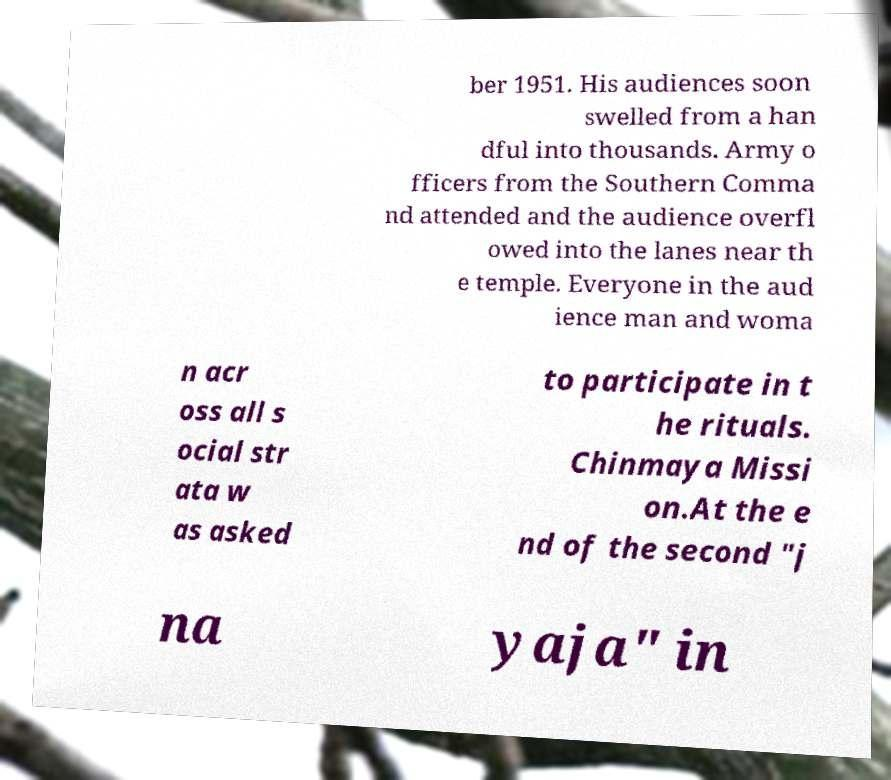Could you extract and type out the text from this image? ber 1951. His audiences soon swelled from a han dful into thousands. Army o fficers from the Southern Comma nd attended and the audience overfl owed into the lanes near th e temple. Everyone in the aud ience man and woma n acr oss all s ocial str ata w as asked to participate in t he rituals. Chinmaya Missi on.At the e nd of the second "j na yaja" in 